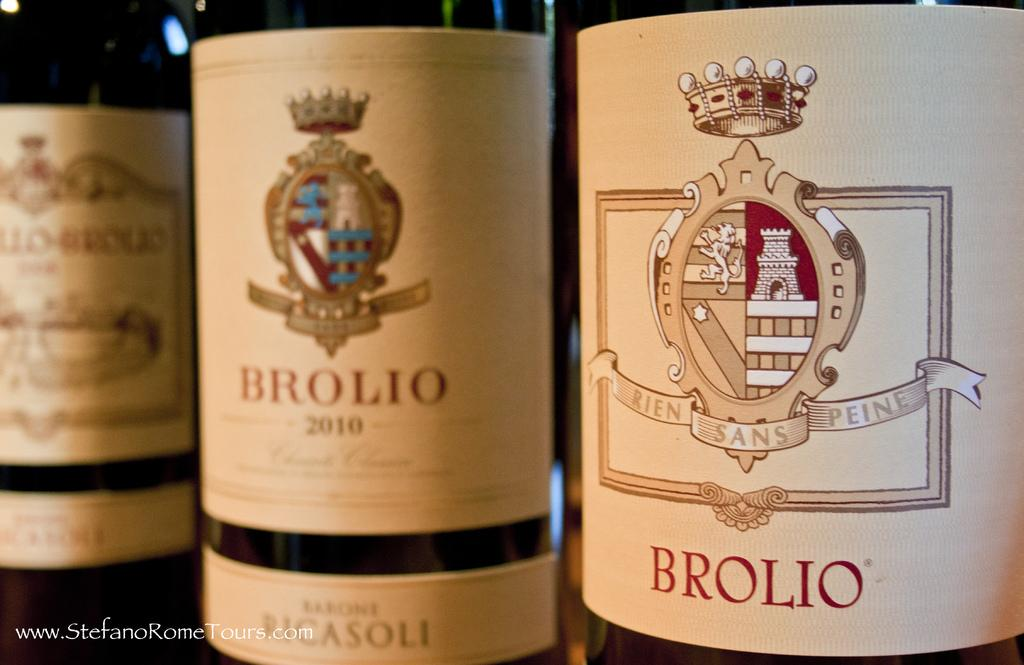<image>
Render a clear and concise summary of the photo. Three bottles of Brolio are sitting in a row next to each other. 